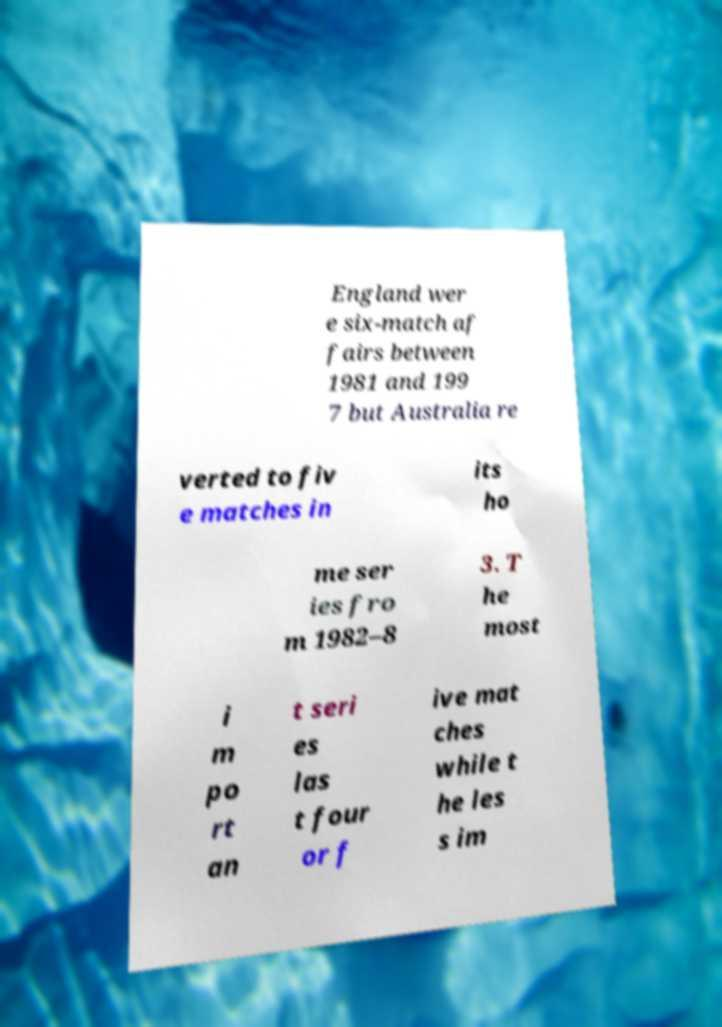Please identify and transcribe the text found in this image. England wer e six-match af fairs between 1981 and 199 7 but Australia re verted to fiv e matches in its ho me ser ies fro m 1982–8 3. T he most i m po rt an t seri es las t four or f ive mat ches while t he les s im 